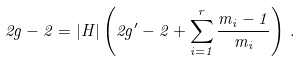<formula> <loc_0><loc_0><loc_500><loc_500>2 g - 2 = | H | \left ( 2 g ^ { \prime } - 2 + \sum _ { i = 1 } ^ { r } \frac { m _ { i } - 1 } { m _ { i } } \right ) \, .</formula> 